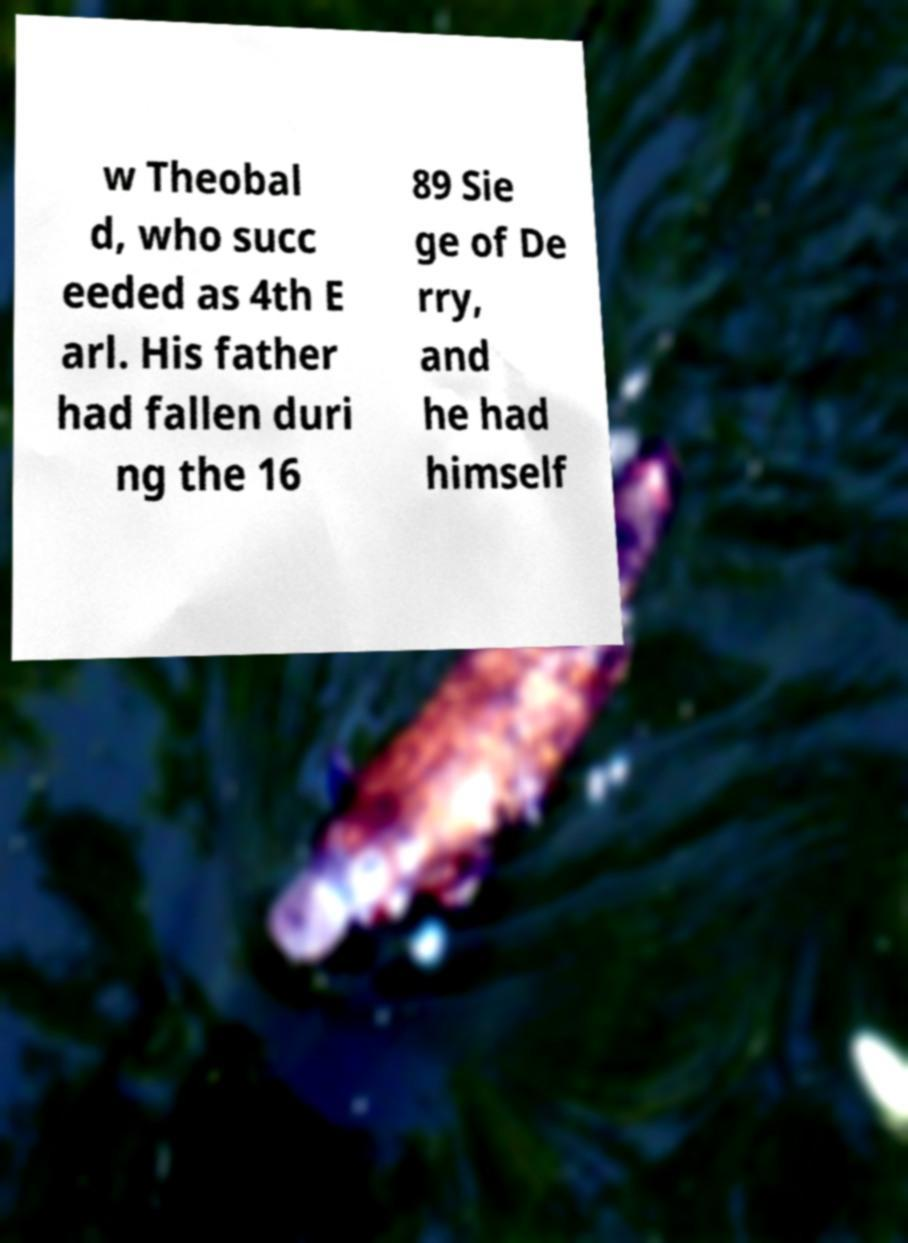Could you assist in decoding the text presented in this image and type it out clearly? w Theobal d, who succ eeded as 4th E arl. His father had fallen duri ng the 16 89 Sie ge of De rry, and he had himself 